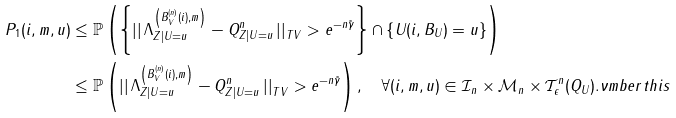Convert formula to latex. <formula><loc_0><loc_0><loc_500><loc_500>P _ { 1 } ( i , m , u ) & \leq \mathbb { P } \left ( \left \{ \left | \right | \Lambda ^ { \left ( B _ { V } ^ { ( n ) } ( i ) , m \right ) } _ { Z | U = u } - Q ^ { n } _ { Z | U = u } \left | \right | _ { T V } > e ^ { - n \tilde { \gamma } } \right \} \cap \left \{ U ( i , B _ { U } ) = u \right \} \right ) \\ & \leq \mathbb { P } \left ( \left | \right | \Lambda ^ { \left ( B _ { V } ^ { ( n ) } ( i ) , m \right ) } _ { Z | U = u } - Q ^ { n } _ { Z | U = u } \left | \right | _ { T V } > e ^ { - n \tilde { \gamma } } \right ) , \quad \forall ( i , m , u ) \in \mathcal { I } _ { n } \times \mathcal { M } _ { n } \times \mathcal { T } _ { \epsilon } ^ { n } ( Q _ { U } ) . \nu m b e r t h i s</formula> 